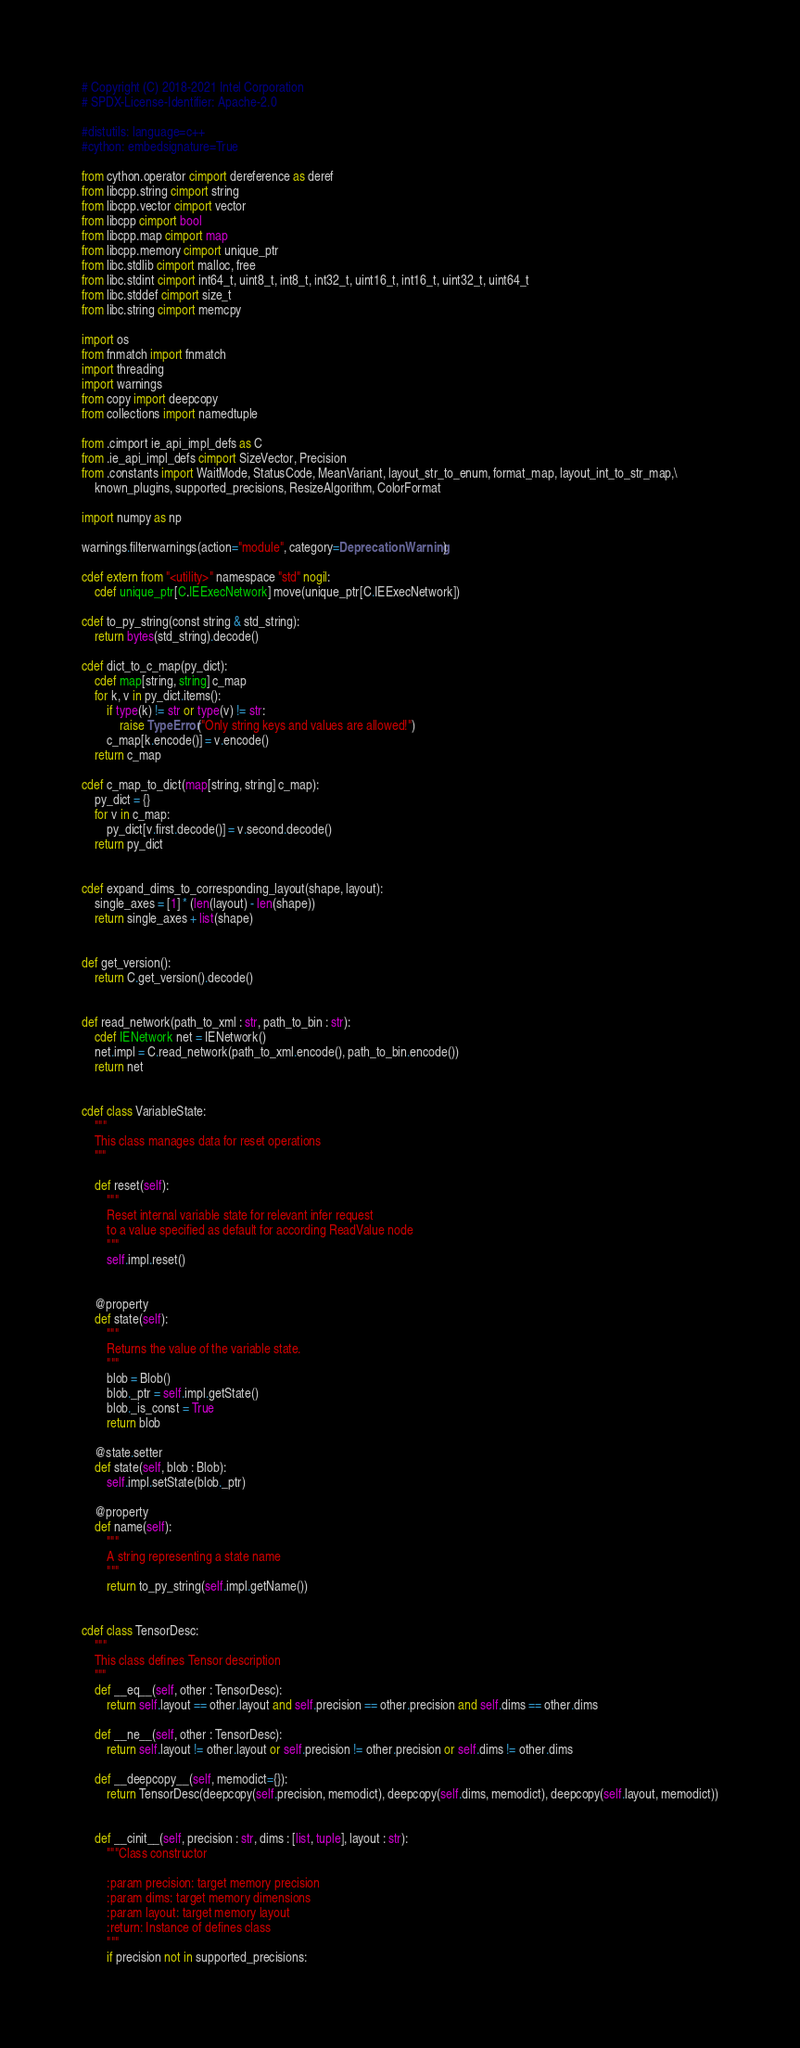Convert code to text. <code><loc_0><loc_0><loc_500><loc_500><_Cython_># Copyright (C) 2018-2021 Intel Corporation
# SPDX-License-Identifier: Apache-2.0

#distutils: language=c++
#cython: embedsignature=True

from cython.operator cimport dereference as deref
from libcpp.string cimport string
from libcpp.vector cimport vector
from libcpp cimport bool
from libcpp.map cimport map
from libcpp.memory cimport unique_ptr
from libc.stdlib cimport malloc, free
from libc.stdint cimport int64_t, uint8_t, int8_t, int32_t, uint16_t, int16_t, uint32_t, uint64_t
from libc.stddef cimport size_t
from libc.string cimport memcpy

import os
from fnmatch import fnmatch
import threading
import warnings
from copy import deepcopy
from collections import namedtuple

from .cimport ie_api_impl_defs as C
from .ie_api_impl_defs cimport SizeVector, Precision
from .constants import WaitMode, StatusCode, MeanVariant, layout_str_to_enum, format_map, layout_int_to_str_map,\
    known_plugins, supported_precisions, ResizeAlgorithm, ColorFormat

import numpy as np

warnings.filterwarnings(action="module", category=DeprecationWarning)

cdef extern from "<utility>" namespace "std" nogil:
    cdef unique_ptr[C.IEExecNetwork] move(unique_ptr[C.IEExecNetwork])

cdef to_py_string(const string & std_string):
    return bytes(std_string).decode()

cdef dict_to_c_map(py_dict):
    cdef map[string, string] c_map
    for k, v in py_dict.items():
        if type(k) != str or type(v) != str:
            raise TypeError("Only string keys and values are allowed!")
        c_map[k.encode()] = v.encode()
    return c_map

cdef c_map_to_dict(map[string, string] c_map):
    py_dict = {}
    for v in c_map:
        py_dict[v.first.decode()] = v.second.decode()
    return py_dict


cdef expand_dims_to_corresponding_layout(shape, layout):
    single_axes = [1] * (len(layout) - len(shape))
    return single_axes + list(shape)


def get_version():
    return C.get_version().decode()


def read_network(path_to_xml : str, path_to_bin : str):
    cdef IENetwork net = IENetwork()
    net.impl = C.read_network(path_to_xml.encode(), path_to_bin.encode())
    return net


cdef class VariableState:
    """
    This class manages data for reset operations
    """

    def reset(self):
        """
        Reset internal variable state for relevant infer request
        to a value specified as default for according ReadValue node
        """
        self.impl.reset()


    @property
    def state(self):
        """
        Returns the value of the variable state.
        """
        blob = Blob()
        blob._ptr = self.impl.getState()
        blob._is_const = True
        return blob

    @state.setter
    def state(self, blob : Blob):
        self.impl.setState(blob._ptr)

    @property
    def name(self):
        """
        A string representing a state name
        """
        return to_py_string(self.impl.getName())


cdef class TensorDesc:
    """
    This class defines Tensor description
    """
    def __eq__(self, other : TensorDesc):
        return self.layout == other.layout and self.precision == other.precision and self.dims == other.dims

    def __ne__(self, other : TensorDesc):
        return self.layout != other.layout or self.precision != other.precision or self.dims != other.dims

    def __deepcopy__(self, memodict={}):
        return TensorDesc(deepcopy(self.precision, memodict), deepcopy(self.dims, memodict), deepcopy(self.layout, memodict))


    def __cinit__(self, precision : str, dims : [list, tuple], layout : str):
        """Class constructor

        :param precision: target memory precision
        :param dims: target memory dimensions
        :param layout: target memory layout
        :return: Instance of defines class
        """
        if precision not in supported_precisions:</code> 